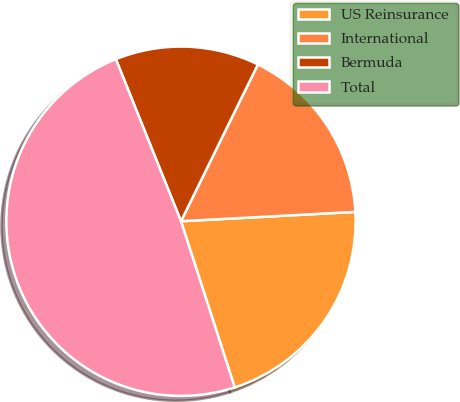Convert chart to OTSL. <chart><loc_0><loc_0><loc_500><loc_500><pie_chart><fcel>US Reinsurance<fcel>International<fcel>Bermuda<fcel>Total<nl><fcel>20.87%<fcel>16.89%<fcel>13.34%<fcel>48.9%<nl></chart> 